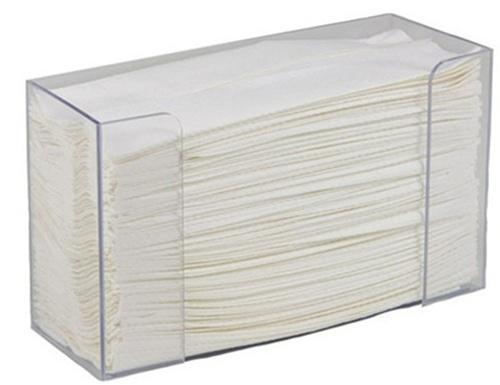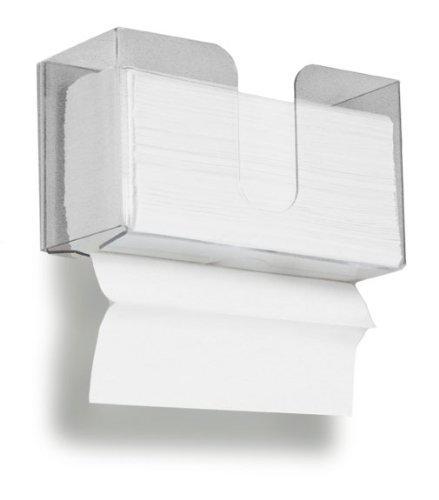The first image is the image on the left, the second image is the image on the right. Analyze the images presented: Is the assertion "At least one image shows a dispenser that is designed to be hung on the wall and fits rectangular napkins." valid? Answer yes or no. Yes. The first image is the image on the left, the second image is the image on the right. Considering the images on both sides, is "An image shows one white paper towel roll on a stand with a post that sticks out at the top." valid? Answer yes or no. No. 